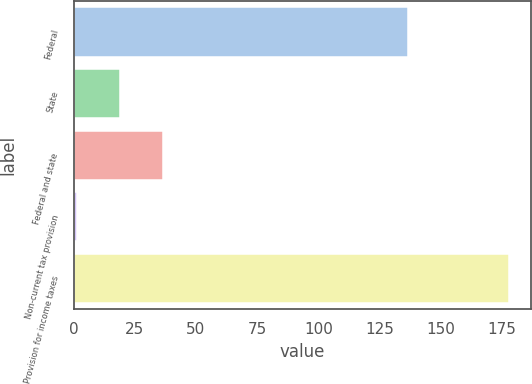<chart> <loc_0><loc_0><loc_500><loc_500><bar_chart><fcel>Federal<fcel>State<fcel>Federal and state<fcel>Non-current tax provision<fcel>Provision for income taxes<nl><fcel>136.8<fcel>18.87<fcel>36.54<fcel>1.2<fcel>177.9<nl></chart> 